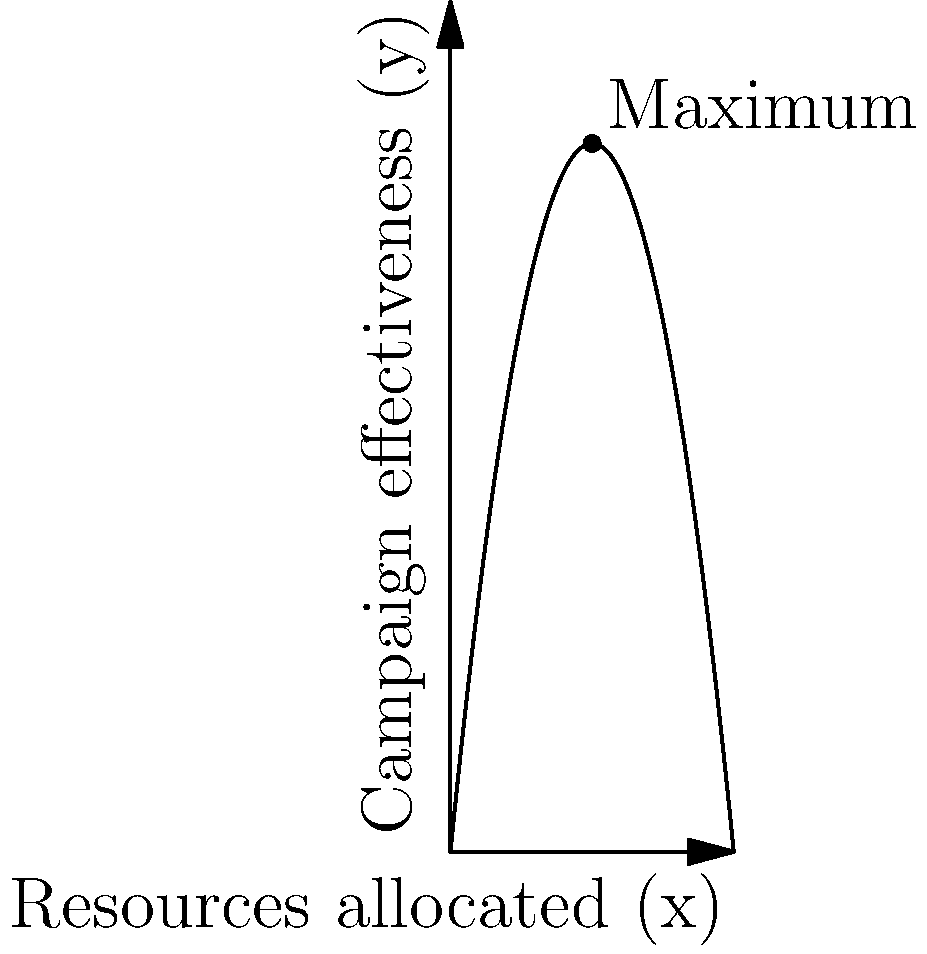A campaign's effectiveness (y) in relation to resources allocated (x) is modeled by the function $y = -0.5x^2 + 10x$, where x is measured in thousands of dollars. What is the optimal amount of resources to allocate to maximize campaign effectiveness, and what is the maximum effectiveness achieved? To find the optimal allocation of resources and maximum effectiveness, we need to follow these steps:

1) First, we need to find the critical point of the function. This is where the derivative equals zero.

2) The derivative of $y = -0.5x^2 + 10x$ is:
   $\frac{dy}{dx} = -x + 10$

3) Set the derivative to zero and solve for x:
   $-x + 10 = 0$
   $x = 10$

4) This critical point (x = 10) represents the optimal allocation of resources.

5) To find the maximum effectiveness, we plug x = 10 into the original function:
   $y = -0.5(10)^2 + 10(10)$
   $y = -50 + 100 = 50$

6) Therefore, the optimal allocation is 10 thousand dollars, and the maximum effectiveness is 50 units.

7) We can verify this is a maximum (not a minimum) because the second derivative is negative:
   $\frac{d^2y}{dx^2} = -1 < 0$

This approach balances the data-driven optimization with a clear, understandable explanation that respects potential skepticism about over-reliance on mathematical models in political decision-making.
Answer: Optimal allocation: $10,000; Maximum effectiveness: 50 